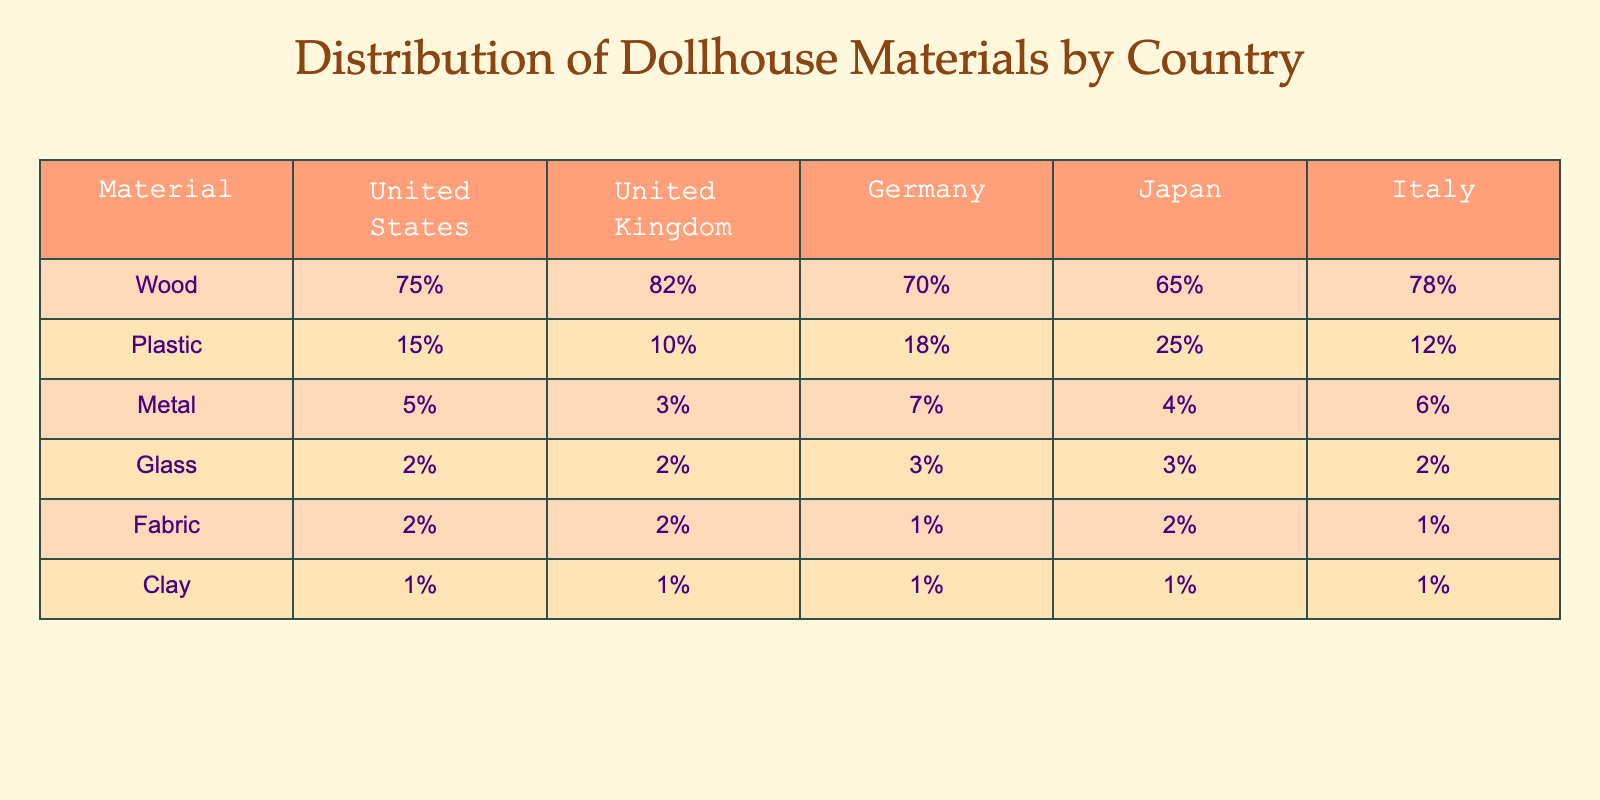What percentage of dollhouse materials used in the United Kingdom is Wood? The table shows that 82% of materials used in the United Kingdom is Wood.
Answer: 82% Which country has the lowest percentage of Metal used in dollhouses? Looking at the table, Japan has the lowest percentage of Metal used at 4%.
Answer: Japan What is the difference in the percentage of Plastic used between the United States and Germany? The United States has 15% Plastic, while Germany has 18%; the difference is 18% - 15% = 3%.
Answer: 3% Does any country use Clay as a significant part of their dollhouse materials? All countries listed have Clay at 1%, which is not a significant percentage compared to other materials.
Answer: No What is the average percentage of Glass used across all five countries? The percentages for Glass are 2%, 2%, 3%, 3%, and 2%. To find the average: (2 + 2 + 3 + 3 + 2) / 5 = 2.4%.
Answer: 2.4% Which material has the highest usage across all countries combined? By adding the percentages, Wood has the highest values across all countries: 75% + 82% + 70% + 65% + 78% = highest overall.
Answer: Wood If we combine the percentage of Fabric and Plastic used in Italy, what do we get? Italy has 12% Plastic and 1% Fabric, so adding these gives 12% + 1% = 13%.
Answer: 13% Is it true that both the United Kingdom and Germany use more than 70% of Wood? The United Kingdom uses 82%, and Germany uses 70%. Both percentages are indeed above 70%.
Answer: Yes What is the total percentage of Fabric and Clay used in Germany? In Germany, Fabric is 1% and Clay is also 1%. Adding these gives 1% + 1% = 2%.
Answer: 2% Which material's usage is constant across all countries? Clay is consistently at 1% in all countries listed in the table.
Answer: Clay 